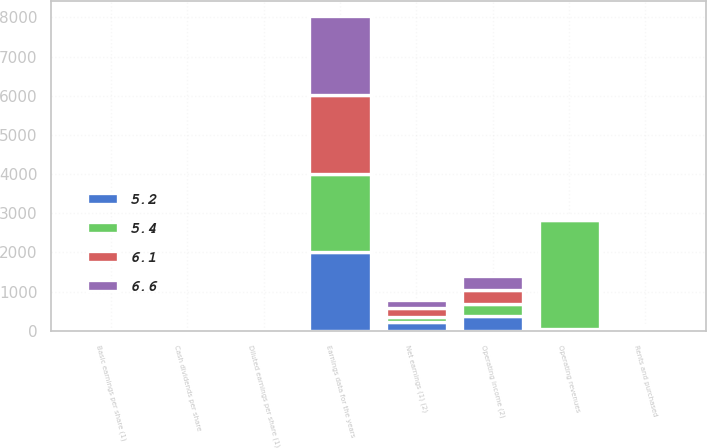<chart> <loc_0><loc_0><loc_500><loc_500><stacked_bar_chart><ecel><fcel>Earnings data for the years<fcel>Operating revenues<fcel>Operating income (2)<fcel>Net earnings (1) (2)<fcel>Basic earnings per share (1)<fcel>Diluted earnings per share (1)<fcel>Cash dividends per share<fcel>Rents and purchased<nl><fcel>6.6<fcel>2008<fcel>35.3<fcel>358<fcel>201<fcel>1.6<fcel>1.56<fcel>0.4<fcel>39.6<nl><fcel>5.2<fcel>2007<fcel>35.3<fcel>369<fcel>213<fcel>1.59<fcel>1.55<fcel>0.36<fcel>35.3<nl><fcel>6.1<fcel>2006<fcel>35.3<fcel>373<fcel>220<fcel>1.48<fcel>1.44<fcel>0.32<fcel>33.8<nl><fcel>5.4<fcel>2004<fcel>2786<fcel>310<fcel>146<fcel>0.91<fcel>0.88<fcel>0.04<fcel>33.5<nl></chart> 